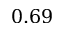Convert formula to latex. <formula><loc_0><loc_0><loc_500><loc_500>0 . 6 9</formula> 